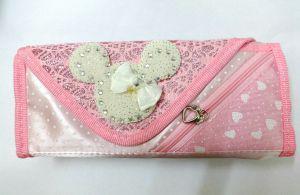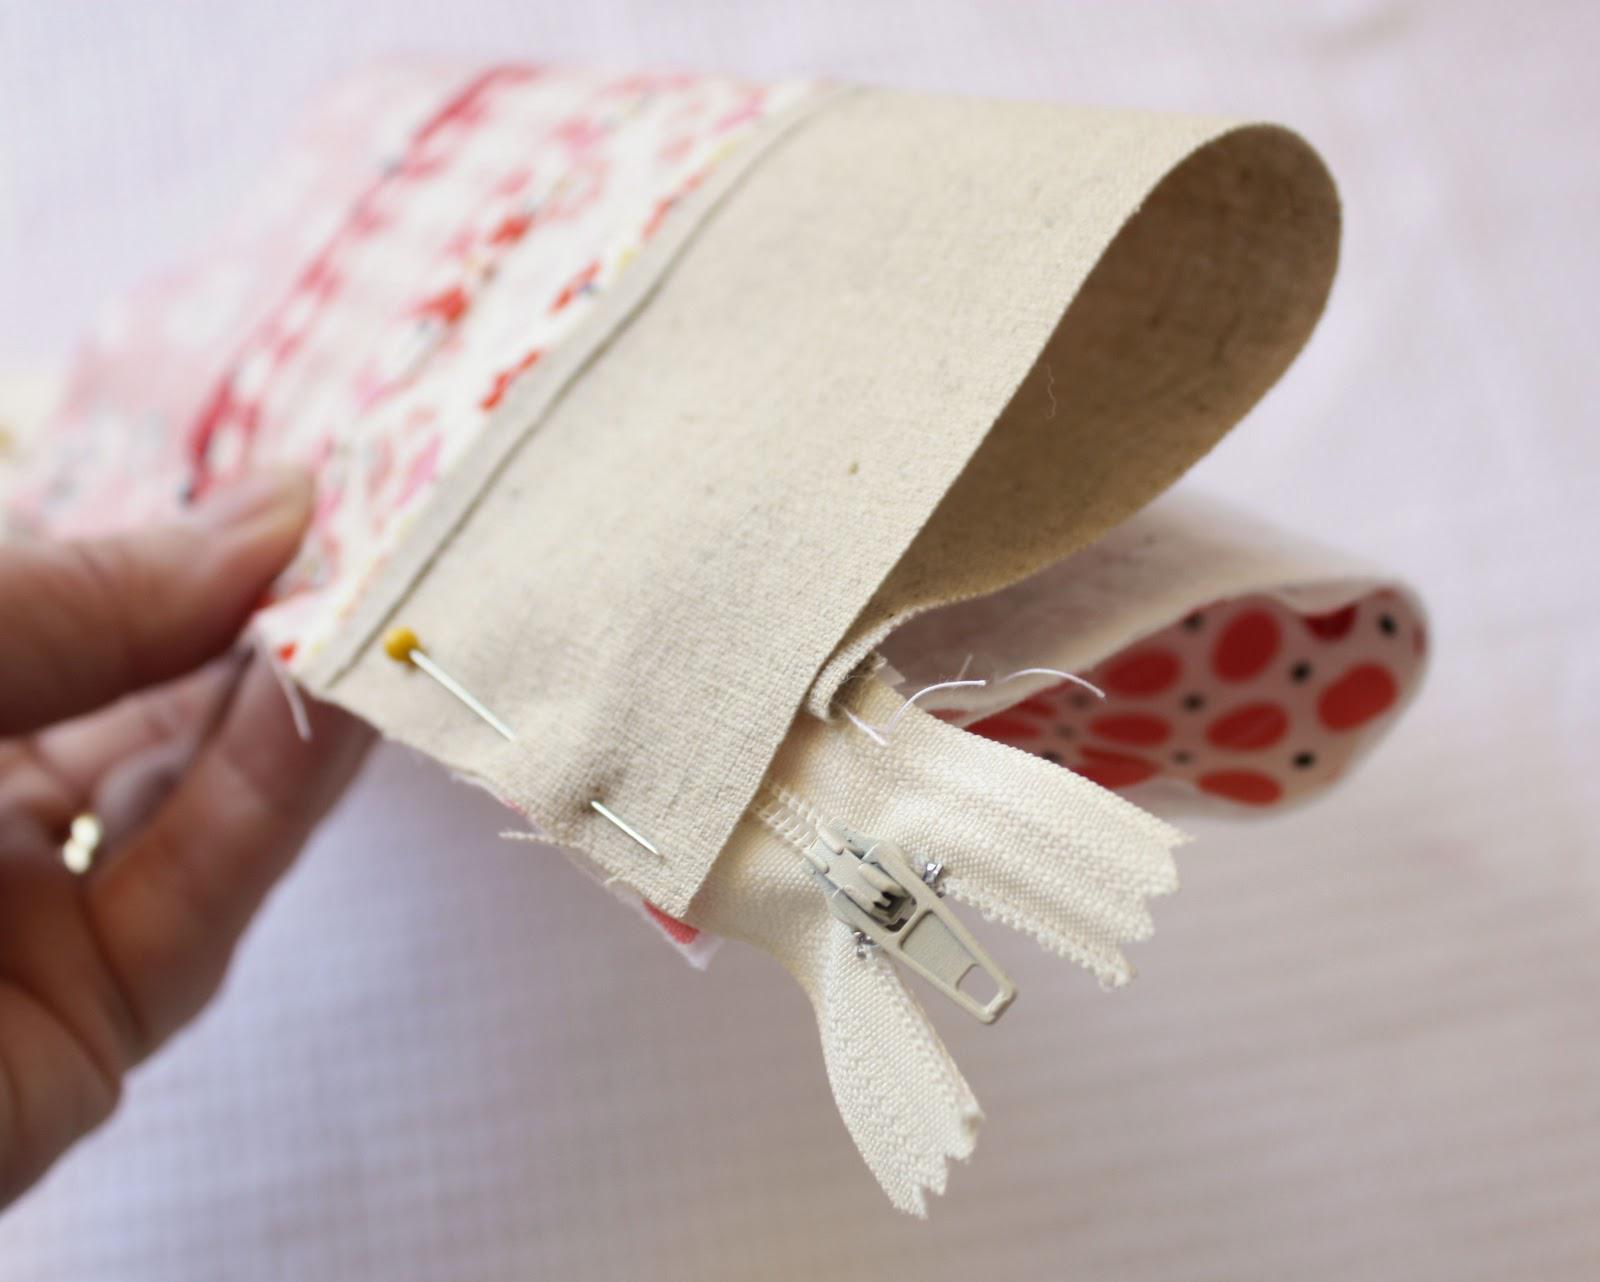The first image is the image on the left, the second image is the image on the right. For the images shown, is this caption "The left image features a case with one zipper across the top, with a charm attached to the zipper pull, and an all-over print depicting cute animals, and the right image shows a mostly pink case closest to the camera." true? Answer yes or no. No. 